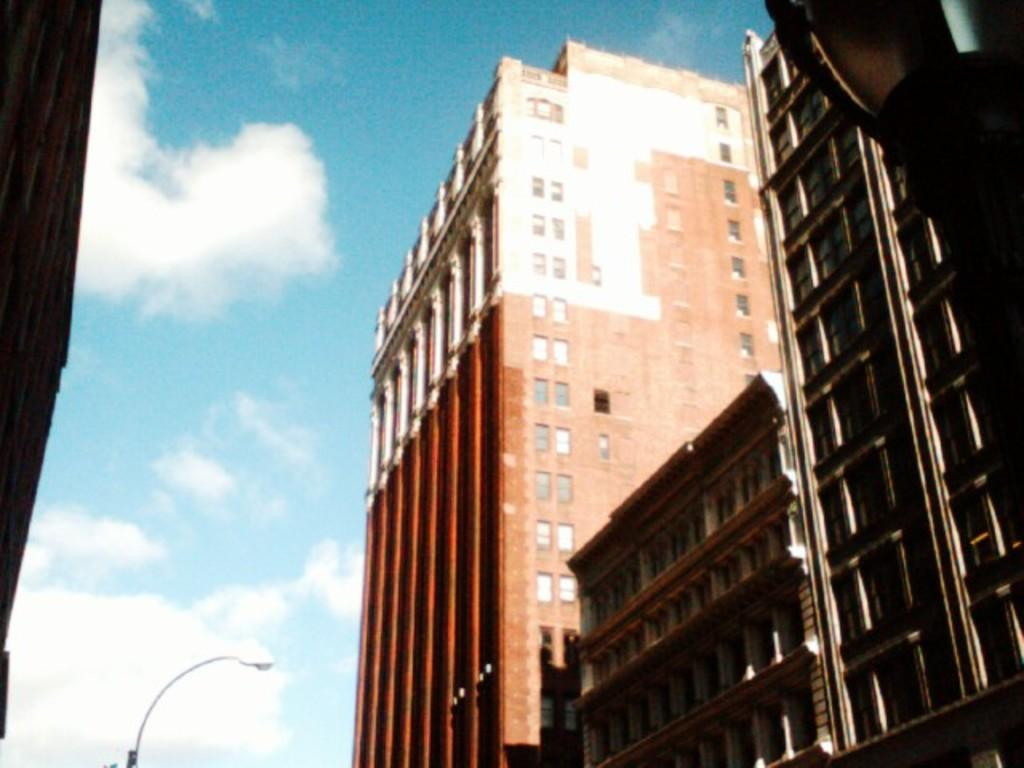What type of structures are located on the right side of the image? There are buildings on the right side of the image. What can be seen at the bottom of the image? There is a pole at the bottom of the image. What is the condition of the sky in the background of the image? The sky in the background of the image is cloudy. What type of stamp can be seen on the buildings in the image? There is no stamp present on the buildings in the image. What shape is the range of mountains in the image? There are no mountains present in the image. 